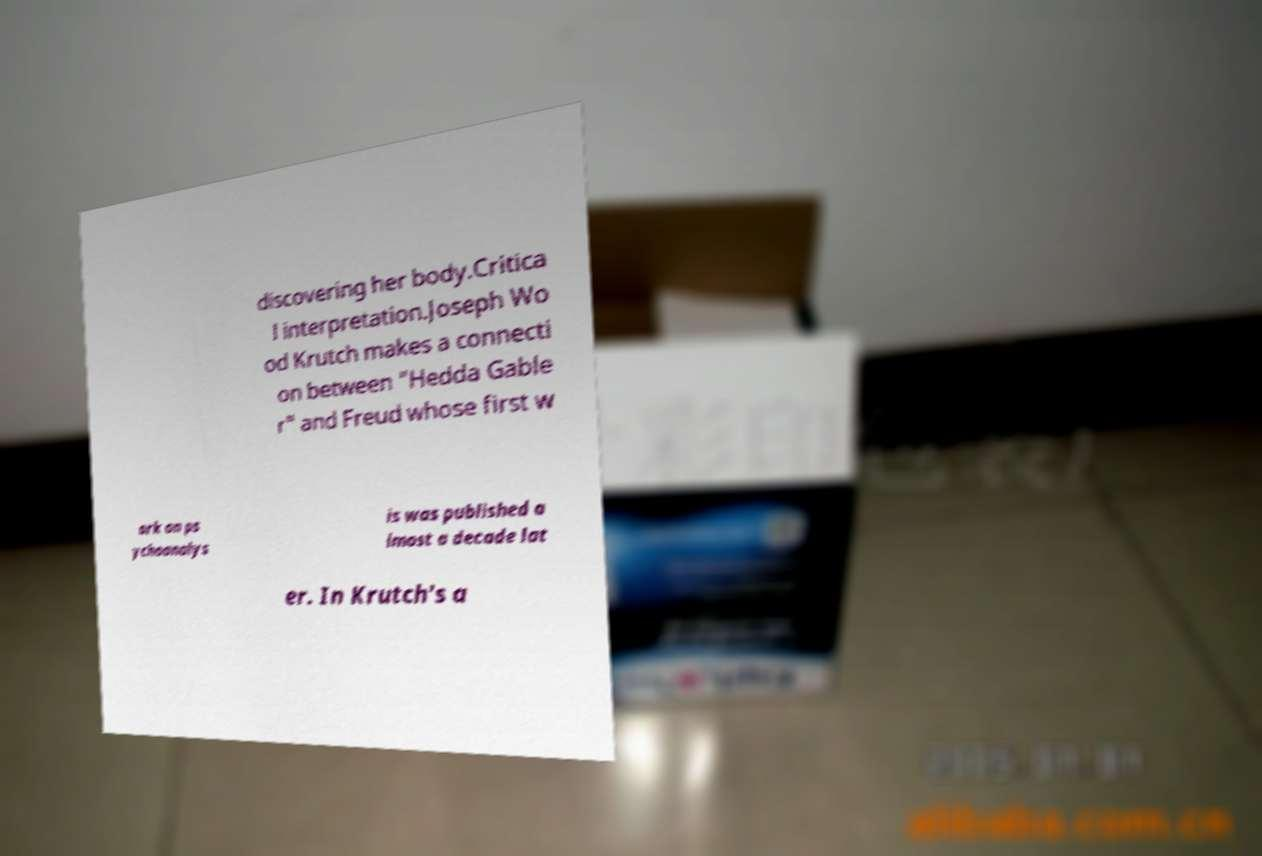There's text embedded in this image that I need extracted. Can you transcribe it verbatim? discovering her body.Critica l interpretation.Joseph Wo od Krutch makes a connecti on between "Hedda Gable r" and Freud whose first w ork on ps ychoanalys is was published a lmost a decade lat er. In Krutch's a 